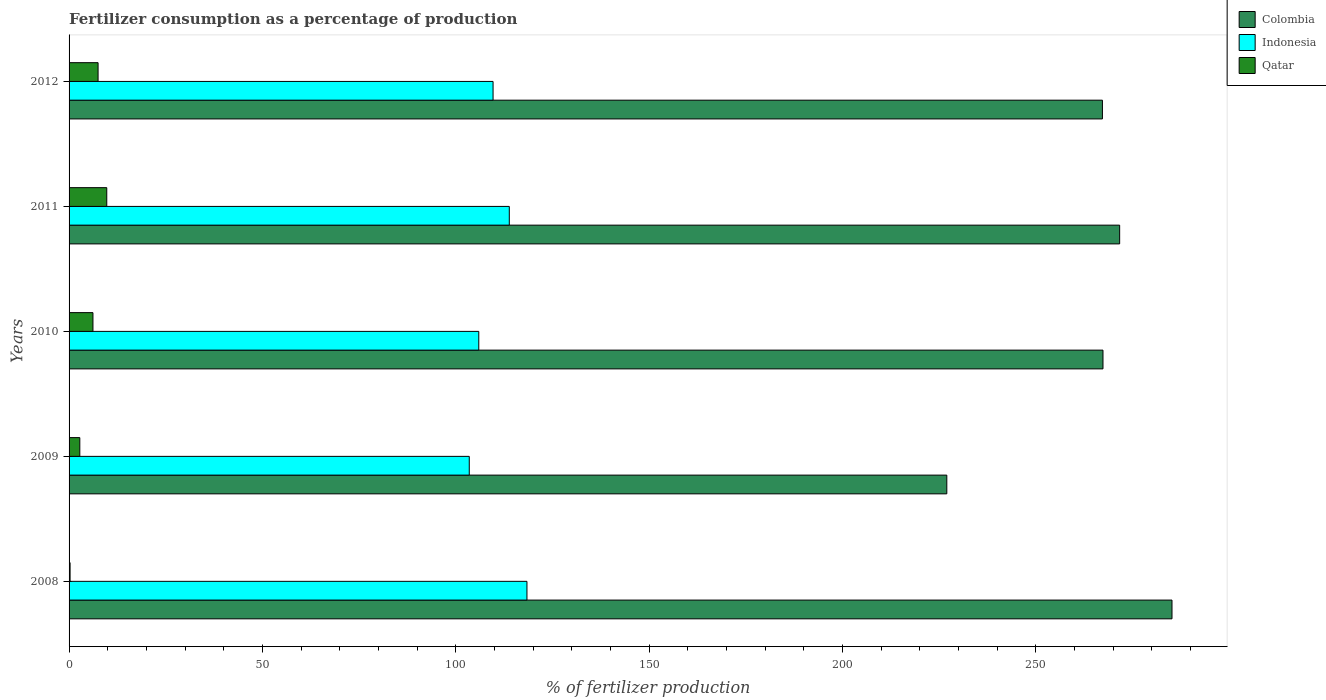How many groups of bars are there?
Keep it short and to the point. 5. Are the number of bars per tick equal to the number of legend labels?
Offer a terse response. Yes. How many bars are there on the 4th tick from the bottom?
Keep it short and to the point. 3. What is the label of the 5th group of bars from the top?
Ensure brevity in your answer.  2008. In how many cases, is the number of bars for a given year not equal to the number of legend labels?
Ensure brevity in your answer.  0. What is the percentage of fertilizers consumed in Qatar in 2008?
Provide a succinct answer. 0.26. Across all years, what is the maximum percentage of fertilizers consumed in Indonesia?
Ensure brevity in your answer.  118.4. Across all years, what is the minimum percentage of fertilizers consumed in Qatar?
Provide a short and direct response. 0.26. What is the total percentage of fertilizers consumed in Qatar in the graph?
Your answer should be very brief. 26.46. What is the difference between the percentage of fertilizers consumed in Indonesia in 2010 and that in 2012?
Your answer should be very brief. -3.69. What is the difference between the percentage of fertilizers consumed in Indonesia in 2010 and the percentage of fertilizers consumed in Colombia in 2012?
Offer a very short reply. -161.26. What is the average percentage of fertilizers consumed in Indonesia per year?
Provide a short and direct response. 110.26. In the year 2012, what is the difference between the percentage of fertilizers consumed in Colombia and percentage of fertilizers consumed in Qatar?
Your response must be concise. 259.7. In how many years, is the percentage of fertilizers consumed in Colombia greater than 160 %?
Make the answer very short. 5. What is the ratio of the percentage of fertilizers consumed in Indonesia in 2009 to that in 2010?
Offer a terse response. 0.98. Is the percentage of fertilizers consumed in Colombia in 2010 less than that in 2012?
Give a very brief answer. No. What is the difference between the highest and the second highest percentage of fertilizers consumed in Colombia?
Offer a very short reply. 13.54. What is the difference between the highest and the lowest percentage of fertilizers consumed in Qatar?
Offer a terse response. 9.49. In how many years, is the percentage of fertilizers consumed in Indonesia greater than the average percentage of fertilizers consumed in Indonesia taken over all years?
Make the answer very short. 2. Is the sum of the percentage of fertilizers consumed in Indonesia in 2010 and 2011 greater than the maximum percentage of fertilizers consumed in Qatar across all years?
Ensure brevity in your answer.  Yes. How many bars are there?
Offer a very short reply. 15. How many years are there in the graph?
Offer a very short reply. 5. What is the difference between two consecutive major ticks on the X-axis?
Offer a terse response. 50. Does the graph contain grids?
Provide a succinct answer. No. Where does the legend appear in the graph?
Give a very brief answer. Top right. How are the legend labels stacked?
Ensure brevity in your answer.  Vertical. What is the title of the graph?
Your answer should be compact. Fertilizer consumption as a percentage of production. Does "Bahrain" appear as one of the legend labels in the graph?
Offer a very short reply. No. What is the label or title of the X-axis?
Offer a very short reply. % of fertilizer production. What is the label or title of the Y-axis?
Ensure brevity in your answer.  Years. What is the % of fertilizer production of Colombia in 2008?
Offer a terse response. 285.19. What is the % of fertilizer production of Indonesia in 2008?
Make the answer very short. 118.4. What is the % of fertilizer production of Qatar in 2008?
Your response must be concise. 0.26. What is the % of fertilizer production in Colombia in 2009?
Your answer should be very brief. 226.96. What is the % of fertilizer production in Indonesia in 2009?
Keep it short and to the point. 103.48. What is the % of fertilizer production of Qatar in 2009?
Your answer should be compact. 2.78. What is the % of fertilizer production in Colombia in 2010?
Keep it short and to the point. 267.34. What is the % of fertilizer production of Indonesia in 2010?
Your answer should be compact. 105.94. What is the % of fertilizer production of Qatar in 2010?
Offer a very short reply. 6.17. What is the % of fertilizer production in Colombia in 2011?
Your answer should be compact. 271.65. What is the % of fertilizer production in Indonesia in 2011?
Provide a succinct answer. 113.83. What is the % of fertilizer production in Qatar in 2011?
Offer a terse response. 9.75. What is the % of fertilizer production of Colombia in 2012?
Your response must be concise. 267.2. What is the % of fertilizer production in Indonesia in 2012?
Keep it short and to the point. 109.63. What is the % of fertilizer production of Qatar in 2012?
Your answer should be very brief. 7.5. Across all years, what is the maximum % of fertilizer production in Colombia?
Provide a short and direct response. 285.19. Across all years, what is the maximum % of fertilizer production in Indonesia?
Provide a succinct answer. 118.4. Across all years, what is the maximum % of fertilizer production of Qatar?
Give a very brief answer. 9.75. Across all years, what is the minimum % of fertilizer production in Colombia?
Keep it short and to the point. 226.96. Across all years, what is the minimum % of fertilizer production in Indonesia?
Your response must be concise. 103.48. Across all years, what is the minimum % of fertilizer production in Qatar?
Offer a terse response. 0.26. What is the total % of fertilizer production of Colombia in the graph?
Your answer should be compact. 1318.35. What is the total % of fertilizer production in Indonesia in the graph?
Give a very brief answer. 551.28. What is the total % of fertilizer production in Qatar in the graph?
Offer a very short reply. 26.46. What is the difference between the % of fertilizer production in Colombia in 2008 and that in 2009?
Offer a very short reply. 58.23. What is the difference between the % of fertilizer production in Indonesia in 2008 and that in 2009?
Your response must be concise. 14.92. What is the difference between the % of fertilizer production in Qatar in 2008 and that in 2009?
Ensure brevity in your answer.  -2.52. What is the difference between the % of fertilizer production in Colombia in 2008 and that in 2010?
Your answer should be very brief. 17.85. What is the difference between the % of fertilizer production of Indonesia in 2008 and that in 2010?
Keep it short and to the point. 12.46. What is the difference between the % of fertilizer production in Qatar in 2008 and that in 2010?
Your answer should be compact. -5.91. What is the difference between the % of fertilizer production of Colombia in 2008 and that in 2011?
Provide a short and direct response. 13.54. What is the difference between the % of fertilizer production of Indonesia in 2008 and that in 2011?
Provide a short and direct response. 4.57. What is the difference between the % of fertilizer production in Qatar in 2008 and that in 2011?
Make the answer very short. -9.49. What is the difference between the % of fertilizer production of Colombia in 2008 and that in 2012?
Offer a very short reply. 17.99. What is the difference between the % of fertilizer production in Indonesia in 2008 and that in 2012?
Give a very brief answer. 8.77. What is the difference between the % of fertilizer production in Qatar in 2008 and that in 2012?
Your answer should be very brief. -7.24. What is the difference between the % of fertilizer production of Colombia in 2009 and that in 2010?
Provide a short and direct response. -40.38. What is the difference between the % of fertilizer production of Indonesia in 2009 and that in 2010?
Offer a very short reply. -2.46. What is the difference between the % of fertilizer production of Qatar in 2009 and that in 2010?
Provide a short and direct response. -3.4. What is the difference between the % of fertilizer production in Colombia in 2009 and that in 2011?
Your answer should be very brief. -44.69. What is the difference between the % of fertilizer production in Indonesia in 2009 and that in 2011?
Provide a short and direct response. -10.35. What is the difference between the % of fertilizer production of Qatar in 2009 and that in 2011?
Offer a very short reply. -6.97. What is the difference between the % of fertilizer production in Colombia in 2009 and that in 2012?
Ensure brevity in your answer.  -40.24. What is the difference between the % of fertilizer production of Indonesia in 2009 and that in 2012?
Your answer should be very brief. -6.15. What is the difference between the % of fertilizer production of Qatar in 2009 and that in 2012?
Offer a very short reply. -4.72. What is the difference between the % of fertilizer production of Colombia in 2010 and that in 2011?
Provide a succinct answer. -4.31. What is the difference between the % of fertilizer production of Indonesia in 2010 and that in 2011?
Keep it short and to the point. -7.89. What is the difference between the % of fertilizer production in Qatar in 2010 and that in 2011?
Your answer should be compact. -3.57. What is the difference between the % of fertilizer production in Colombia in 2010 and that in 2012?
Your answer should be very brief. 0.15. What is the difference between the % of fertilizer production of Indonesia in 2010 and that in 2012?
Keep it short and to the point. -3.69. What is the difference between the % of fertilizer production in Qatar in 2010 and that in 2012?
Provide a short and direct response. -1.33. What is the difference between the % of fertilizer production in Colombia in 2011 and that in 2012?
Offer a terse response. 4.46. What is the difference between the % of fertilizer production of Indonesia in 2011 and that in 2012?
Give a very brief answer. 4.2. What is the difference between the % of fertilizer production of Qatar in 2011 and that in 2012?
Give a very brief answer. 2.25. What is the difference between the % of fertilizer production of Colombia in 2008 and the % of fertilizer production of Indonesia in 2009?
Provide a short and direct response. 181.71. What is the difference between the % of fertilizer production in Colombia in 2008 and the % of fertilizer production in Qatar in 2009?
Your answer should be very brief. 282.41. What is the difference between the % of fertilizer production in Indonesia in 2008 and the % of fertilizer production in Qatar in 2009?
Provide a short and direct response. 115.62. What is the difference between the % of fertilizer production in Colombia in 2008 and the % of fertilizer production in Indonesia in 2010?
Provide a succinct answer. 179.25. What is the difference between the % of fertilizer production of Colombia in 2008 and the % of fertilizer production of Qatar in 2010?
Ensure brevity in your answer.  279.02. What is the difference between the % of fertilizer production in Indonesia in 2008 and the % of fertilizer production in Qatar in 2010?
Your response must be concise. 112.22. What is the difference between the % of fertilizer production in Colombia in 2008 and the % of fertilizer production in Indonesia in 2011?
Offer a terse response. 171.36. What is the difference between the % of fertilizer production in Colombia in 2008 and the % of fertilizer production in Qatar in 2011?
Keep it short and to the point. 275.44. What is the difference between the % of fertilizer production of Indonesia in 2008 and the % of fertilizer production of Qatar in 2011?
Your response must be concise. 108.65. What is the difference between the % of fertilizer production of Colombia in 2008 and the % of fertilizer production of Indonesia in 2012?
Keep it short and to the point. 175.56. What is the difference between the % of fertilizer production of Colombia in 2008 and the % of fertilizer production of Qatar in 2012?
Your answer should be very brief. 277.69. What is the difference between the % of fertilizer production of Indonesia in 2008 and the % of fertilizer production of Qatar in 2012?
Your answer should be very brief. 110.9. What is the difference between the % of fertilizer production in Colombia in 2009 and the % of fertilizer production in Indonesia in 2010?
Offer a very short reply. 121.02. What is the difference between the % of fertilizer production of Colombia in 2009 and the % of fertilizer production of Qatar in 2010?
Offer a very short reply. 220.79. What is the difference between the % of fertilizer production of Indonesia in 2009 and the % of fertilizer production of Qatar in 2010?
Provide a succinct answer. 97.3. What is the difference between the % of fertilizer production in Colombia in 2009 and the % of fertilizer production in Indonesia in 2011?
Offer a very short reply. 113.13. What is the difference between the % of fertilizer production in Colombia in 2009 and the % of fertilizer production in Qatar in 2011?
Your response must be concise. 217.21. What is the difference between the % of fertilizer production in Indonesia in 2009 and the % of fertilizer production in Qatar in 2011?
Keep it short and to the point. 93.73. What is the difference between the % of fertilizer production of Colombia in 2009 and the % of fertilizer production of Indonesia in 2012?
Provide a short and direct response. 117.33. What is the difference between the % of fertilizer production of Colombia in 2009 and the % of fertilizer production of Qatar in 2012?
Provide a short and direct response. 219.46. What is the difference between the % of fertilizer production of Indonesia in 2009 and the % of fertilizer production of Qatar in 2012?
Your response must be concise. 95.98. What is the difference between the % of fertilizer production of Colombia in 2010 and the % of fertilizer production of Indonesia in 2011?
Offer a very short reply. 153.51. What is the difference between the % of fertilizer production in Colombia in 2010 and the % of fertilizer production in Qatar in 2011?
Give a very brief answer. 257.6. What is the difference between the % of fertilizer production of Indonesia in 2010 and the % of fertilizer production of Qatar in 2011?
Your answer should be very brief. 96.19. What is the difference between the % of fertilizer production in Colombia in 2010 and the % of fertilizer production in Indonesia in 2012?
Offer a very short reply. 157.71. What is the difference between the % of fertilizer production in Colombia in 2010 and the % of fertilizer production in Qatar in 2012?
Your answer should be very brief. 259.84. What is the difference between the % of fertilizer production in Indonesia in 2010 and the % of fertilizer production in Qatar in 2012?
Provide a succinct answer. 98.44. What is the difference between the % of fertilizer production in Colombia in 2011 and the % of fertilizer production in Indonesia in 2012?
Provide a succinct answer. 162.02. What is the difference between the % of fertilizer production in Colombia in 2011 and the % of fertilizer production in Qatar in 2012?
Ensure brevity in your answer.  264.15. What is the difference between the % of fertilizer production of Indonesia in 2011 and the % of fertilizer production of Qatar in 2012?
Make the answer very short. 106.33. What is the average % of fertilizer production in Colombia per year?
Offer a very short reply. 263.67. What is the average % of fertilizer production of Indonesia per year?
Your answer should be compact. 110.26. What is the average % of fertilizer production of Qatar per year?
Give a very brief answer. 5.29. In the year 2008, what is the difference between the % of fertilizer production in Colombia and % of fertilizer production in Indonesia?
Your response must be concise. 166.79. In the year 2008, what is the difference between the % of fertilizer production of Colombia and % of fertilizer production of Qatar?
Make the answer very short. 284.93. In the year 2008, what is the difference between the % of fertilizer production in Indonesia and % of fertilizer production in Qatar?
Your answer should be compact. 118.14. In the year 2009, what is the difference between the % of fertilizer production of Colombia and % of fertilizer production of Indonesia?
Provide a short and direct response. 123.48. In the year 2009, what is the difference between the % of fertilizer production of Colombia and % of fertilizer production of Qatar?
Provide a short and direct response. 224.19. In the year 2009, what is the difference between the % of fertilizer production in Indonesia and % of fertilizer production in Qatar?
Give a very brief answer. 100.7. In the year 2010, what is the difference between the % of fertilizer production in Colombia and % of fertilizer production in Indonesia?
Your response must be concise. 161.4. In the year 2010, what is the difference between the % of fertilizer production of Colombia and % of fertilizer production of Qatar?
Your answer should be compact. 261.17. In the year 2010, what is the difference between the % of fertilizer production in Indonesia and % of fertilizer production in Qatar?
Your response must be concise. 99.77. In the year 2011, what is the difference between the % of fertilizer production in Colombia and % of fertilizer production in Indonesia?
Offer a very short reply. 157.82. In the year 2011, what is the difference between the % of fertilizer production of Colombia and % of fertilizer production of Qatar?
Provide a short and direct response. 261.91. In the year 2011, what is the difference between the % of fertilizer production in Indonesia and % of fertilizer production in Qatar?
Keep it short and to the point. 104.08. In the year 2012, what is the difference between the % of fertilizer production in Colombia and % of fertilizer production in Indonesia?
Your answer should be compact. 157.57. In the year 2012, what is the difference between the % of fertilizer production in Colombia and % of fertilizer production in Qatar?
Your answer should be very brief. 259.7. In the year 2012, what is the difference between the % of fertilizer production of Indonesia and % of fertilizer production of Qatar?
Offer a very short reply. 102.13. What is the ratio of the % of fertilizer production in Colombia in 2008 to that in 2009?
Offer a very short reply. 1.26. What is the ratio of the % of fertilizer production in Indonesia in 2008 to that in 2009?
Your answer should be very brief. 1.14. What is the ratio of the % of fertilizer production of Qatar in 2008 to that in 2009?
Provide a succinct answer. 0.09. What is the ratio of the % of fertilizer production in Colombia in 2008 to that in 2010?
Your answer should be very brief. 1.07. What is the ratio of the % of fertilizer production in Indonesia in 2008 to that in 2010?
Provide a succinct answer. 1.12. What is the ratio of the % of fertilizer production in Qatar in 2008 to that in 2010?
Your response must be concise. 0.04. What is the ratio of the % of fertilizer production of Colombia in 2008 to that in 2011?
Provide a short and direct response. 1.05. What is the ratio of the % of fertilizer production of Indonesia in 2008 to that in 2011?
Your answer should be very brief. 1.04. What is the ratio of the % of fertilizer production of Qatar in 2008 to that in 2011?
Keep it short and to the point. 0.03. What is the ratio of the % of fertilizer production of Colombia in 2008 to that in 2012?
Keep it short and to the point. 1.07. What is the ratio of the % of fertilizer production in Indonesia in 2008 to that in 2012?
Provide a succinct answer. 1.08. What is the ratio of the % of fertilizer production of Qatar in 2008 to that in 2012?
Your answer should be very brief. 0.03. What is the ratio of the % of fertilizer production in Colombia in 2009 to that in 2010?
Provide a succinct answer. 0.85. What is the ratio of the % of fertilizer production in Indonesia in 2009 to that in 2010?
Offer a very short reply. 0.98. What is the ratio of the % of fertilizer production of Qatar in 2009 to that in 2010?
Make the answer very short. 0.45. What is the ratio of the % of fertilizer production of Colombia in 2009 to that in 2011?
Keep it short and to the point. 0.84. What is the ratio of the % of fertilizer production of Qatar in 2009 to that in 2011?
Your answer should be compact. 0.28. What is the ratio of the % of fertilizer production in Colombia in 2009 to that in 2012?
Provide a short and direct response. 0.85. What is the ratio of the % of fertilizer production in Indonesia in 2009 to that in 2012?
Give a very brief answer. 0.94. What is the ratio of the % of fertilizer production of Qatar in 2009 to that in 2012?
Provide a succinct answer. 0.37. What is the ratio of the % of fertilizer production of Colombia in 2010 to that in 2011?
Make the answer very short. 0.98. What is the ratio of the % of fertilizer production in Indonesia in 2010 to that in 2011?
Ensure brevity in your answer.  0.93. What is the ratio of the % of fertilizer production of Qatar in 2010 to that in 2011?
Your answer should be compact. 0.63. What is the ratio of the % of fertilizer production of Colombia in 2010 to that in 2012?
Provide a succinct answer. 1. What is the ratio of the % of fertilizer production of Indonesia in 2010 to that in 2012?
Make the answer very short. 0.97. What is the ratio of the % of fertilizer production in Qatar in 2010 to that in 2012?
Your answer should be very brief. 0.82. What is the ratio of the % of fertilizer production in Colombia in 2011 to that in 2012?
Your answer should be very brief. 1.02. What is the ratio of the % of fertilizer production of Indonesia in 2011 to that in 2012?
Provide a succinct answer. 1.04. What is the ratio of the % of fertilizer production of Qatar in 2011 to that in 2012?
Your response must be concise. 1.3. What is the difference between the highest and the second highest % of fertilizer production in Colombia?
Make the answer very short. 13.54. What is the difference between the highest and the second highest % of fertilizer production of Indonesia?
Offer a terse response. 4.57. What is the difference between the highest and the second highest % of fertilizer production in Qatar?
Your answer should be very brief. 2.25. What is the difference between the highest and the lowest % of fertilizer production in Colombia?
Keep it short and to the point. 58.23. What is the difference between the highest and the lowest % of fertilizer production of Indonesia?
Your answer should be compact. 14.92. What is the difference between the highest and the lowest % of fertilizer production of Qatar?
Your answer should be compact. 9.49. 